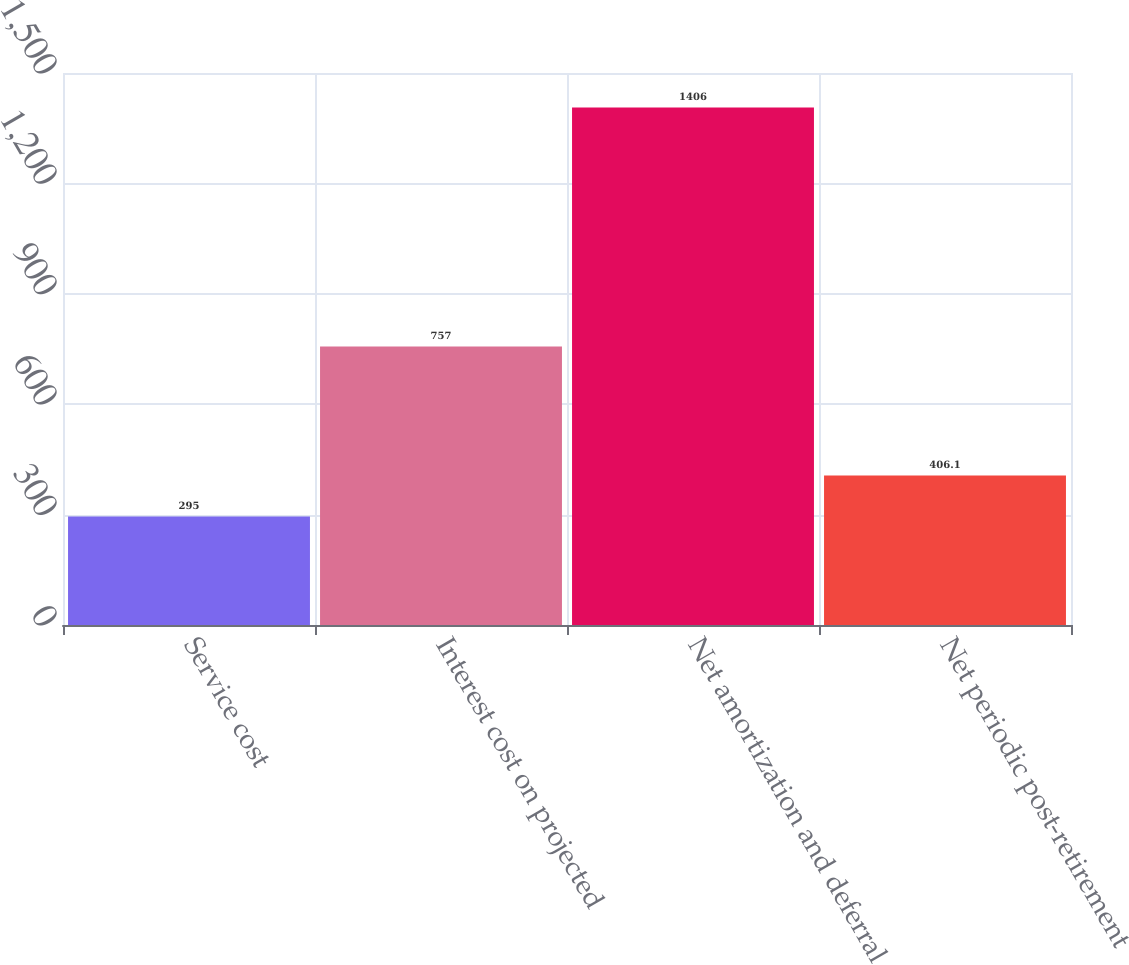Convert chart. <chart><loc_0><loc_0><loc_500><loc_500><bar_chart><fcel>Service cost<fcel>Interest cost on projected<fcel>Net amortization and deferral<fcel>Net periodic post-retirement<nl><fcel>295<fcel>757<fcel>1406<fcel>406.1<nl></chart> 